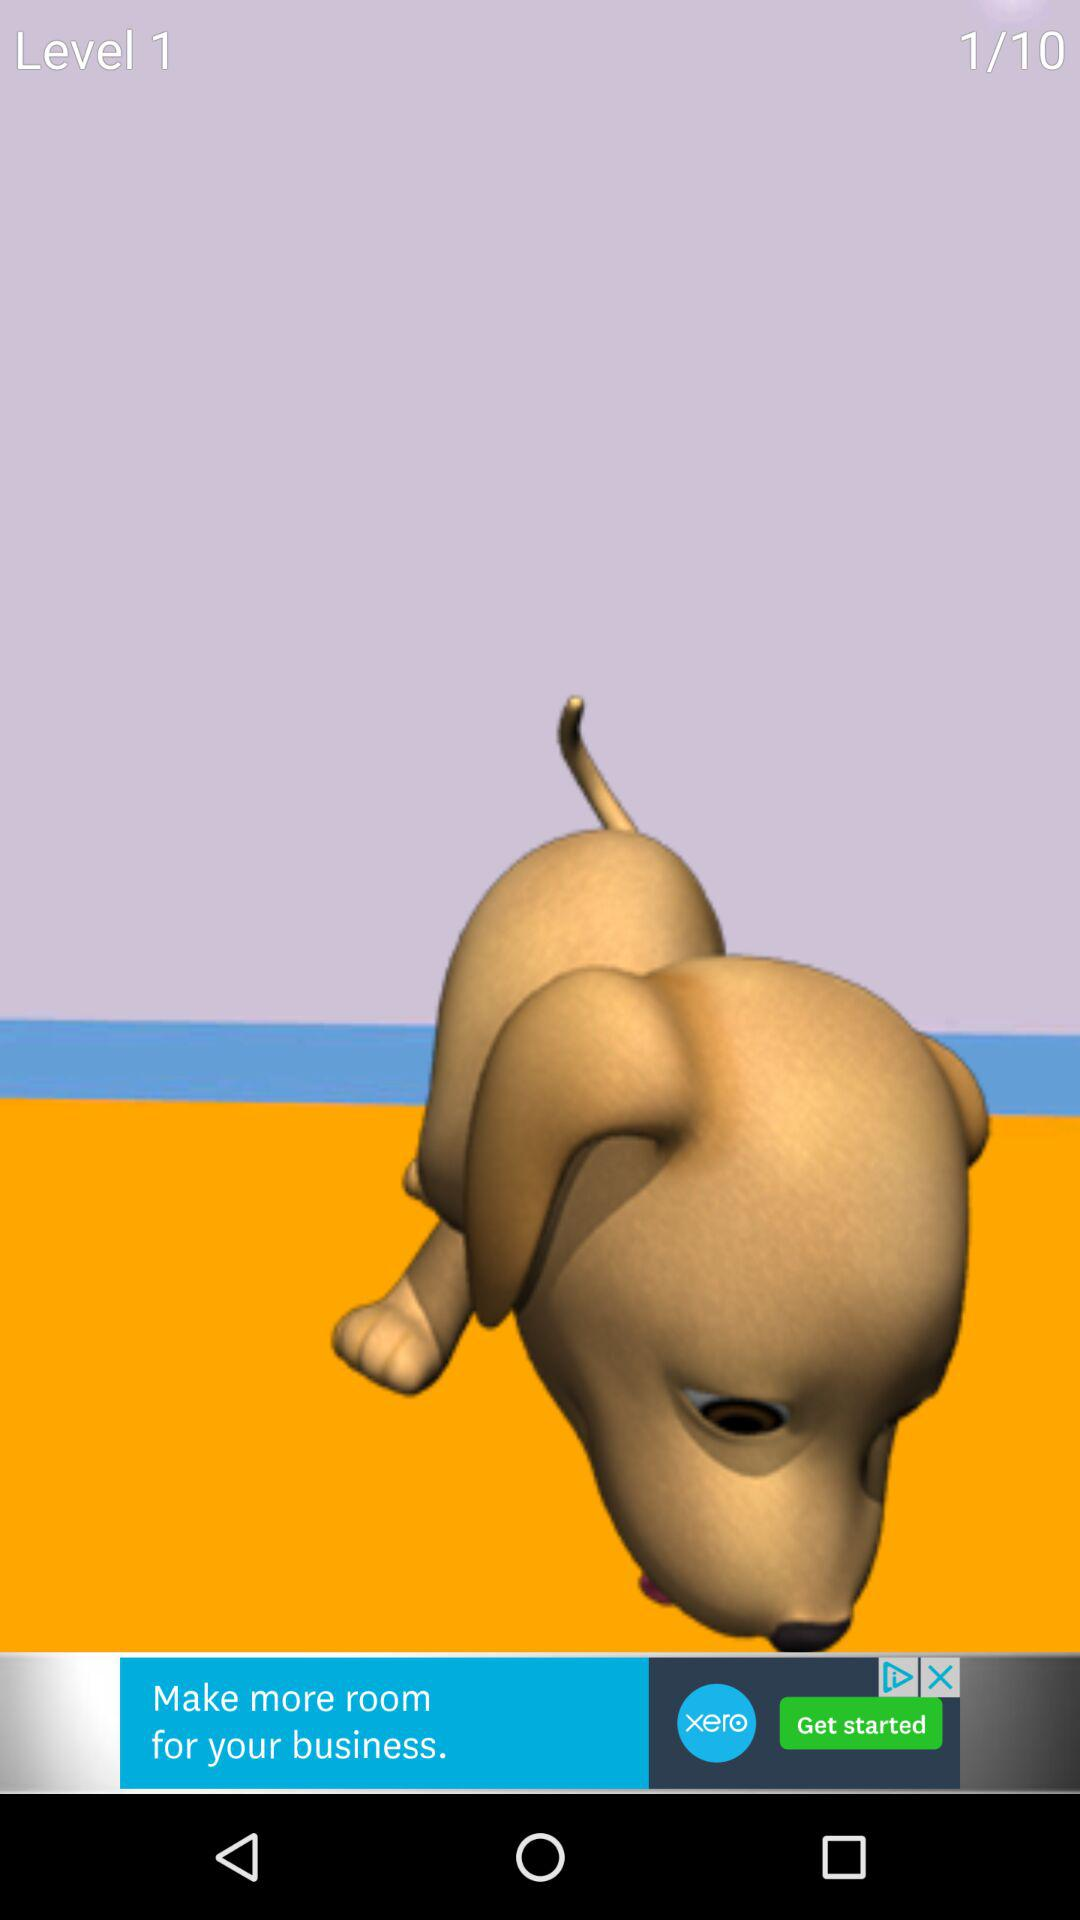What is the level? The level is 1. 